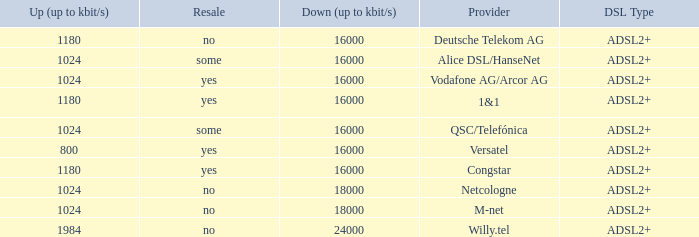What is download bandwith where the provider is deutsche telekom ag? 16000.0. 